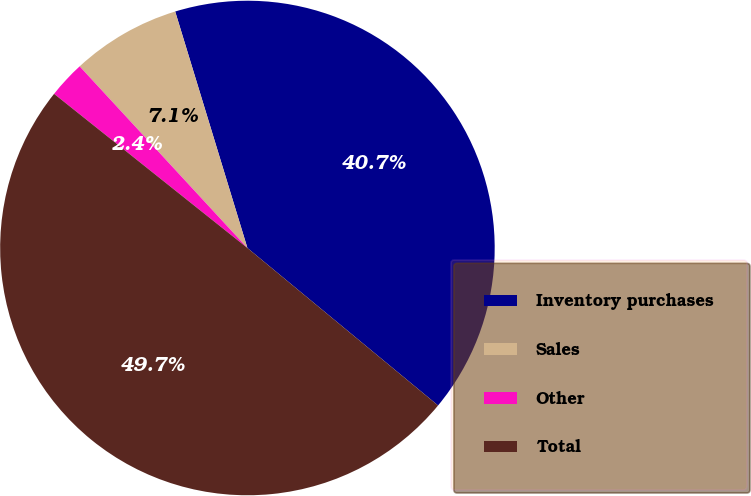Convert chart to OTSL. <chart><loc_0><loc_0><loc_500><loc_500><pie_chart><fcel>Inventory purchases<fcel>Sales<fcel>Other<fcel>Total<nl><fcel>40.71%<fcel>7.15%<fcel>2.42%<fcel>49.73%<nl></chart> 